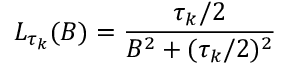Convert formula to latex. <formula><loc_0><loc_0><loc_500><loc_500>L _ { \tau _ { k } } ( B ) = \frac { \tau _ { k } / 2 } { B ^ { 2 } + ( \tau _ { k } / 2 ) ^ { 2 } }</formula> 